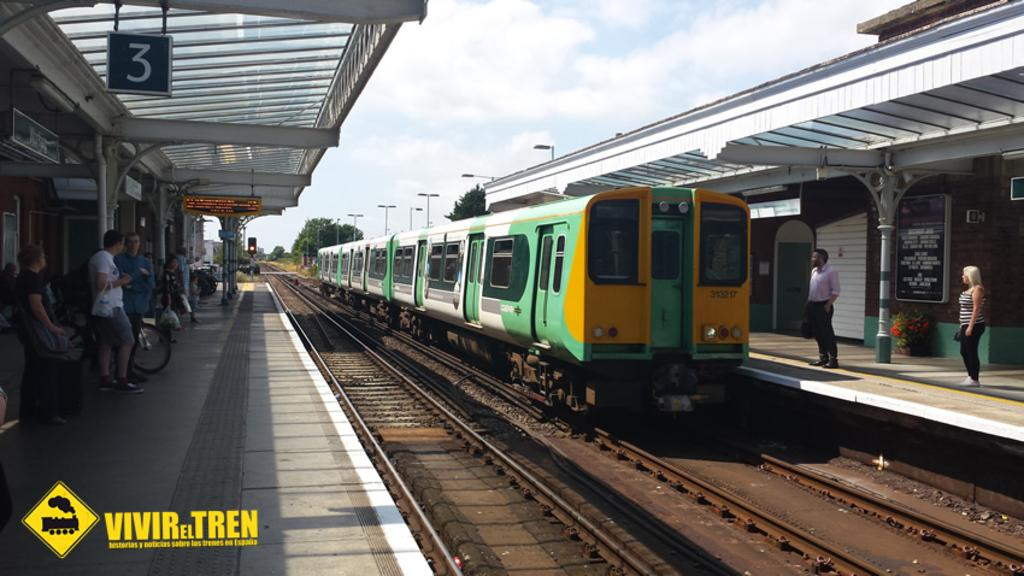<image>
Provide a brief description of the given image. Vivir el Tren features train histories, notes, and trains at train stations. 